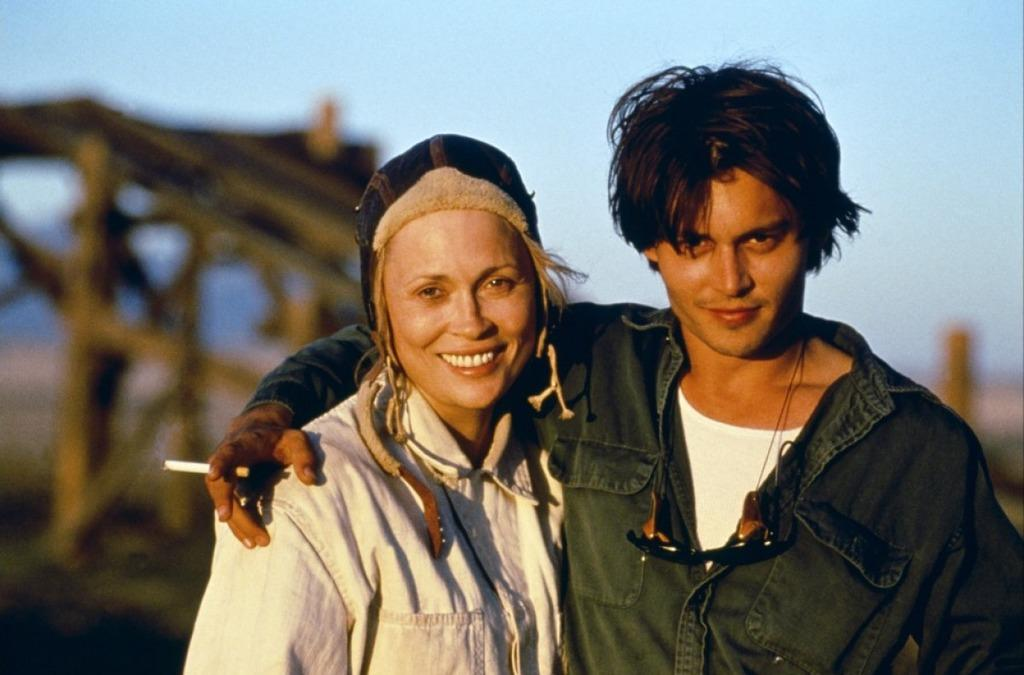What is the man in the image holding? The man is holding a cigarette. What is the woman in the image doing? The woman is standing. How would you describe the background of the image? The background of the image is blurry. What can be seen in the sky in the background of the image? The sky is visible in the background of the image. What other objects are visible in the background of the image? There are other objects visible in the background of the image. What type of sorting does the man in the image perform with the cigarette? The man in the image is not performing any sorting with the cigarette; he is simply holding it. 